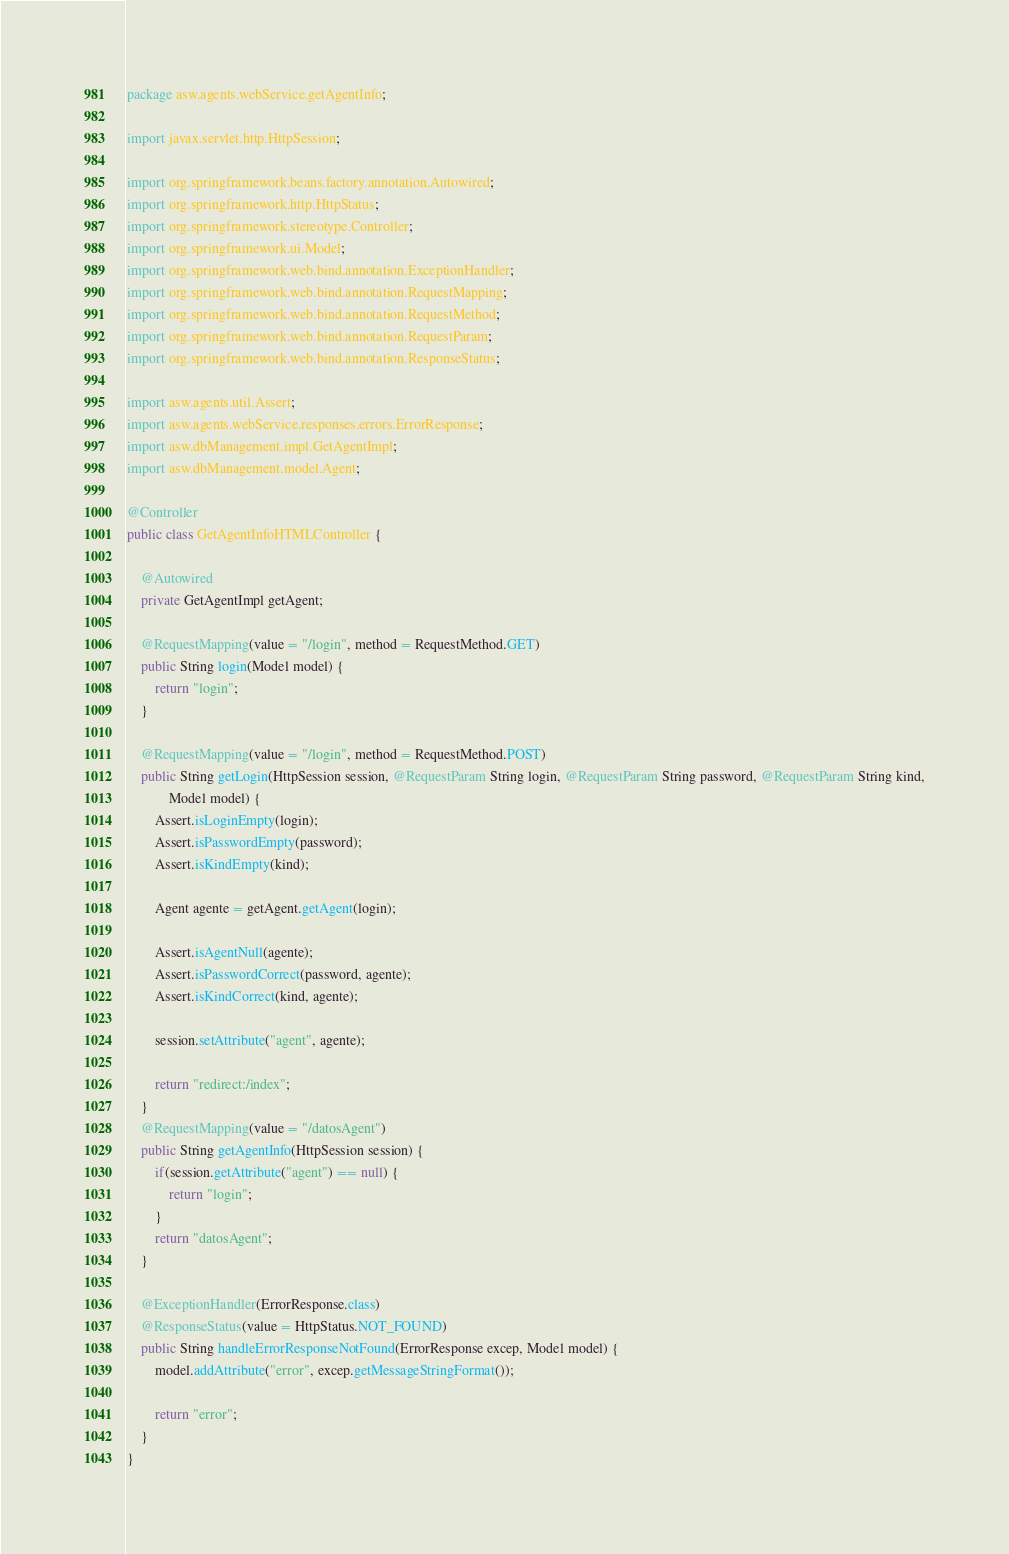Convert code to text. <code><loc_0><loc_0><loc_500><loc_500><_Java_>package asw.agents.webService.getAgentInfo;

import javax.servlet.http.HttpSession;

import org.springframework.beans.factory.annotation.Autowired;
import org.springframework.http.HttpStatus;
import org.springframework.stereotype.Controller;
import org.springframework.ui.Model;
import org.springframework.web.bind.annotation.ExceptionHandler;
import org.springframework.web.bind.annotation.RequestMapping;
import org.springframework.web.bind.annotation.RequestMethod;
import org.springframework.web.bind.annotation.RequestParam;
import org.springframework.web.bind.annotation.ResponseStatus;

import asw.agents.util.Assert;
import asw.agents.webService.responses.errors.ErrorResponse;
import asw.dbManagement.impl.GetAgentImpl;
import asw.dbManagement.model.Agent;

@Controller
public class GetAgentInfoHTMLController {

	@Autowired
	private GetAgentImpl getAgent;

	@RequestMapping(value = "/login", method = RequestMethod.GET)
	public String login(Model model) {
		return "login";
	}
	
	@RequestMapping(value = "/login", method = RequestMethod.POST)
	public String getLogin(HttpSession session, @RequestParam String login, @RequestParam String password, @RequestParam String kind,
			Model model) {
		Assert.isLoginEmpty(login);
		Assert.isPasswordEmpty(password);
		Assert.isKindEmpty(kind);

		Agent agente = getAgent.getAgent(login);

		Assert.isAgentNull(agente);
		Assert.isPasswordCorrect(password, agente);
		Assert.isKindCorrect(kind, agente);

		session.setAttribute("agent", agente);
		
		return "redirect:/index";
	}
	@RequestMapping(value = "/datosAgent")
	public String getAgentInfo(HttpSession session) {
		if(session.getAttribute("agent") == null) {
			return "login";
		}
		return "datosAgent";
	}

	@ExceptionHandler(ErrorResponse.class)
	@ResponseStatus(value = HttpStatus.NOT_FOUND)
	public String handleErrorResponseNotFound(ErrorResponse excep, Model model) {
		model.addAttribute("error", excep.getMessageStringFormat());

		return "error";
	}
}
</code> 